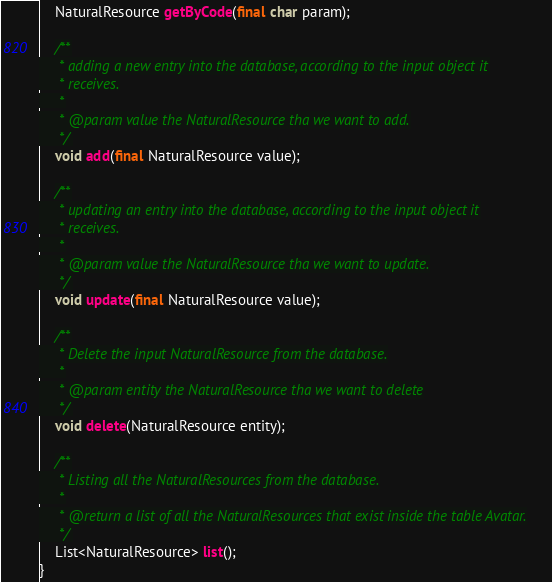<code> <loc_0><loc_0><loc_500><loc_500><_Java_>    NaturalResource getByCode(final char param);

    /**
     * adding a new entry into the database, according to the input object it
     * receives.
     *
     * @param value the NaturalResource tha we want to add.
     */
    void add(final NaturalResource value);

    /**
     * updating an entry into the database, according to the input object it
     * receives.
     *
     * @param value the NaturalResource tha we want to update.
     */
    void update(final NaturalResource value);

    /**
     * Delete the input NaturalResource from the database.
     *
     * @param entity the NaturalResource tha we want to delete
     */
    void delete(NaturalResource entity);

    /**
     * Listing all the NaturalResources from the database.
     *
     * @return a list of all the NaturalResources that exist inside the table Avatar.
     */
    List<NaturalResource> list();
}
</code> 